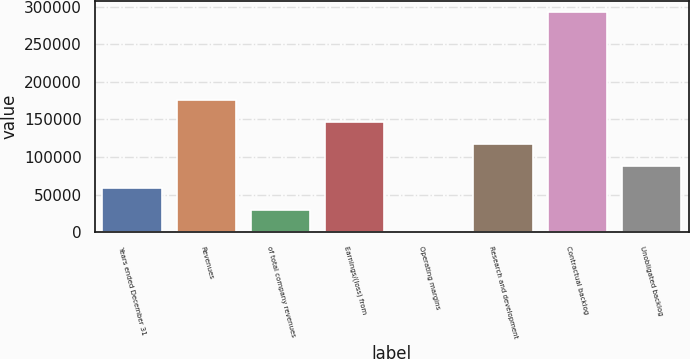Convert chart to OTSL. <chart><loc_0><loc_0><loc_500><loc_500><bar_chart><fcel>Years ended December 31<fcel>Revenues<fcel>of total company revenues<fcel>Earnings/(loss) from<fcel>Operating margins<fcel>Research and development<fcel>Contractual backlog<fcel>Unobligated backlog<nl><fcel>58668.4<fcel>175986<fcel>29339<fcel>146656<fcel>9.7<fcel>117327<fcel>293303<fcel>87997.7<nl></chart> 